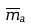<formula> <loc_0><loc_0><loc_500><loc_500>\overline { m } _ { a }</formula> 